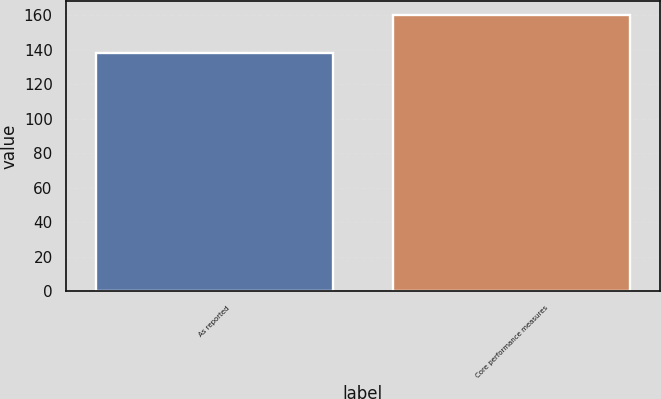Convert chart. <chart><loc_0><loc_0><loc_500><loc_500><bar_chart><fcel>As reported<fcel>Core performance measures<nl><fcel>138<fcel>160<nl></chart> 